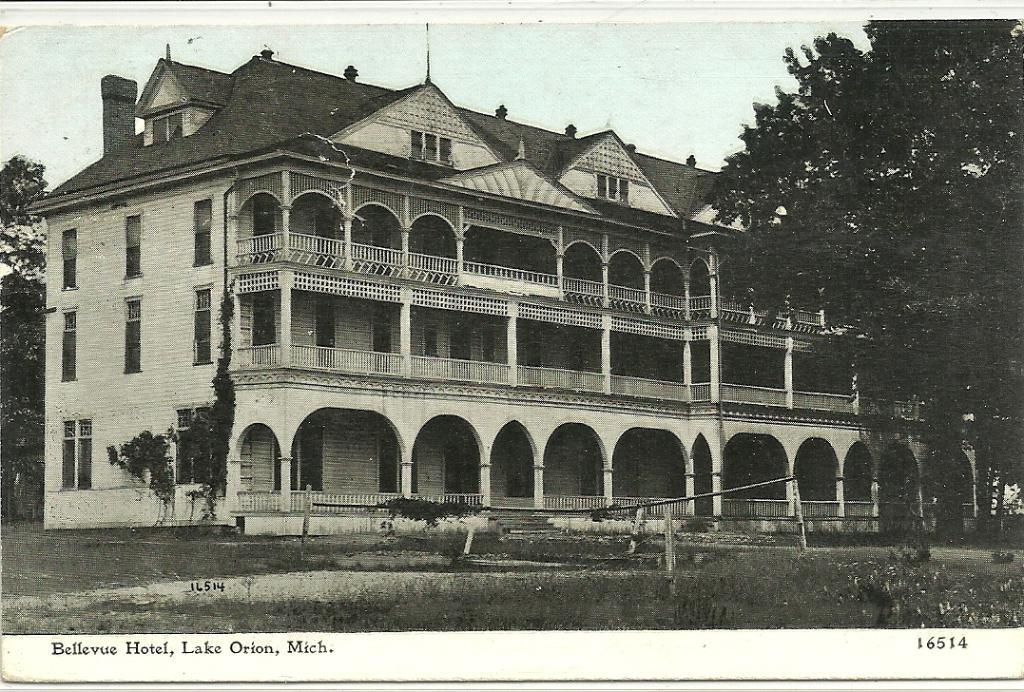What is the color scheme of the image? The image is black and white. What type of vegetation can be seen in the image? There is grass and plants in the image. What type of structure is present in the image? There is a building in the image. What other natural elements can be seen in the image? There are trees in the image. What part of the sky is visible in the image? The sky is visible in the image. What type of leaf is being used to massage the grandfather's stomach in the image? There is no grandfather or stomach massage present in the image. What type of leaf is being used to massage the stomach of the person in the image? There is no person or stomach massage present in the image. 